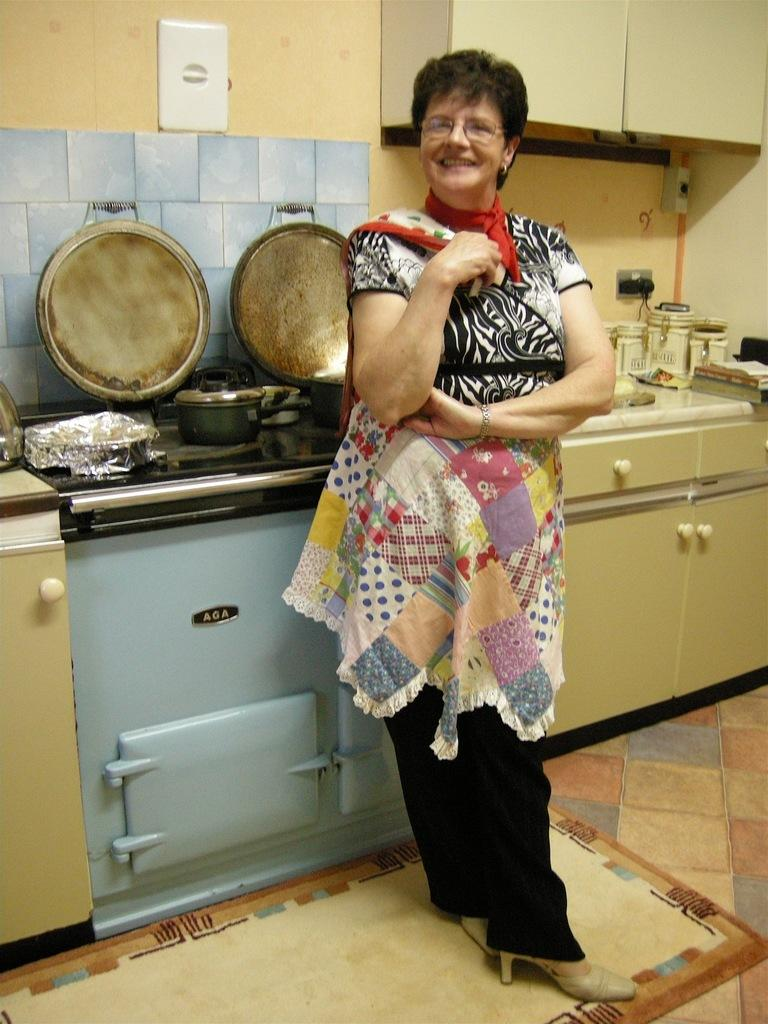<image>
Relay a brief, clear account of the picture shown. A woman stands in front of a blue AGA brand oven. 